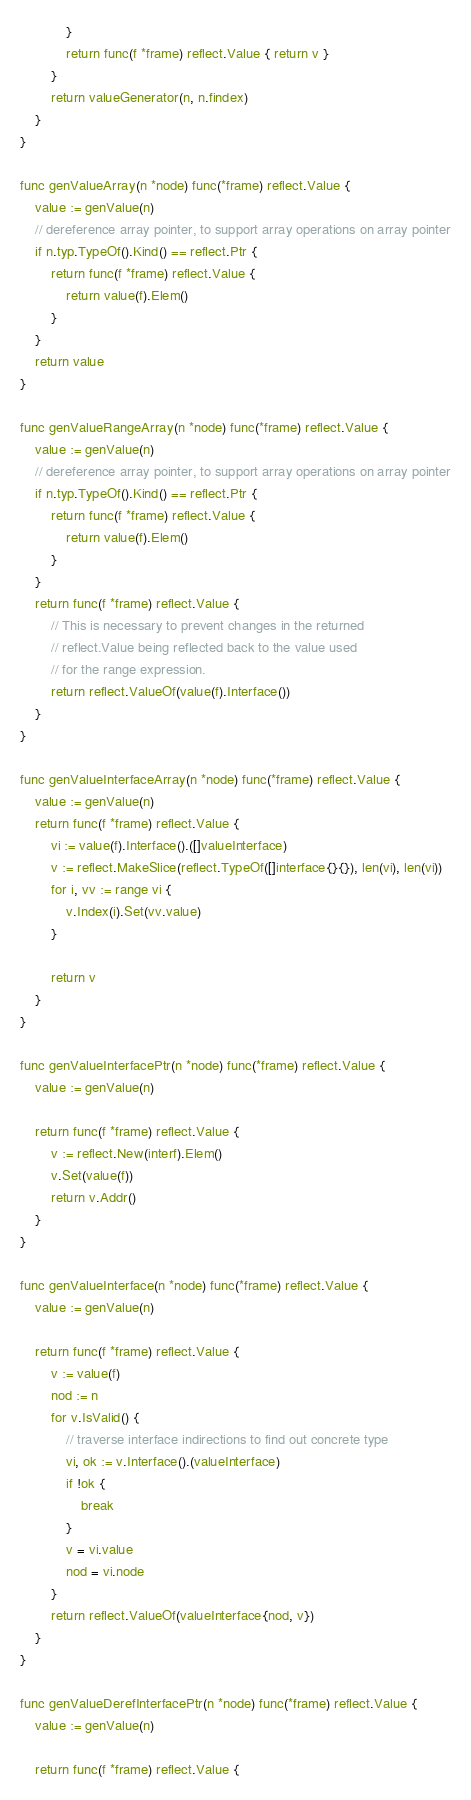Convert code to text. <code><loc_0><loc_0><loc_500><loc_500><_Go_>			}
			return func(f *frame) reflect.Value { return v }
		}
		return valueGenerator(n, n.findex)
	}
}

func genValueArray(n *node) func(*frame) reflect.Value {
	value := genValue(n)
	// dereference array pointer, to support array operations on array pointer
	if n.typ.TypeOf().Kind() == reflect.Ptr {
		return func(f *frame) reflect.Value {
			return value(f).Elem()
		}
	}
	return value
}

func genValueRangeArray(n *node) func(*frame) reflect.Value {
	value := genValue(n)
	// dereference array pointer, to support array operations on array pointer
	if n.typ.TypeOf().Kind() == reflect.Ptr {
		return func(f *frame) reflect.Value {
			return value(f).Elem()
		}
	}
	return func(f *frame) reflect.Value {
		// This is necessary to prevent changes in the returned
		// reflect.Value being reflected back to the value used
		// for the range expression.
		return reflect.ValueOf(value(f).Interface())
	}
}

func genValueInterfaceArray(n *node) func(*frame) reflect.Value {
	value := genValue(n)
	return func(f *frame) reflect.Value {
		vi := value(f).Interface().([]valueInterface)
		v := reflect.MakeSlice(reflect.TypeOf([]interface{}{}), len(vi), len(vi))
		for i, vv := range vi {
			v.Index(i).Set(vv.value)
		}

		return v
	}
}

func genValueInterfacePtr(n *node) func(*frame) reflect.Value {
	value := genValue(n)

	return func(f *frame) reflect.Value {
		v := reflect.New(interf).Elem()
		v.Set(value(f))
		return v.Addr()
	}
}

func genValueInterface(n *node) func(*frame) reflect.Value {
	value := genValue(n)

	return func(f *frame) reflect.Value {
		v := value(f)
		nod := n
		for v.IsValid() {
			// traverse interface indirections to find out concrete type
			vi, ok := v.Interface().(valueInterface)
			if !ok {
				break
			}
			v = vi.value
			nod = vi.node
		}
		return reflect.ValueOf(valueInterface{nod, v})
	}
}

func genValueDerefInterfacePtr(n *node) func(*frame) reflect.Value {
	value := genValue(n)

	return func(f *frame) reflect.Value {</code> 